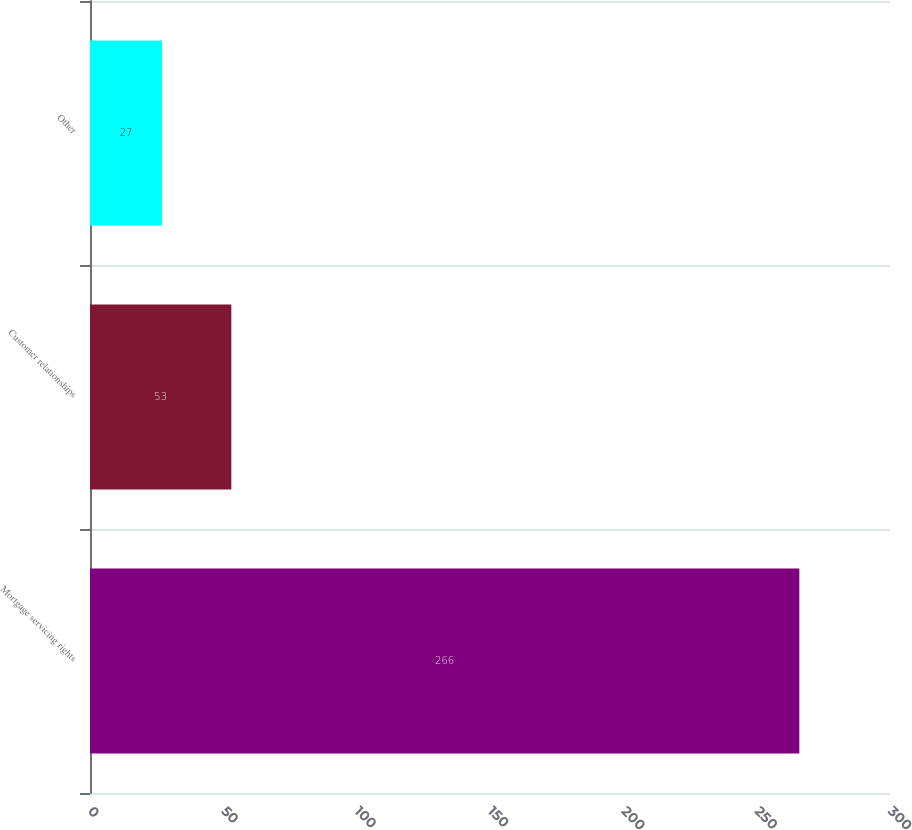Convert chart. <chart><loc_0><loc_0><loc_500><loc_500><bar_chart><fcel>Mortgage servicing rights<fcel>Customer relationships<fcel>Other<nl><fcel>266<fcel>53<fcel>27<nl></chart> 